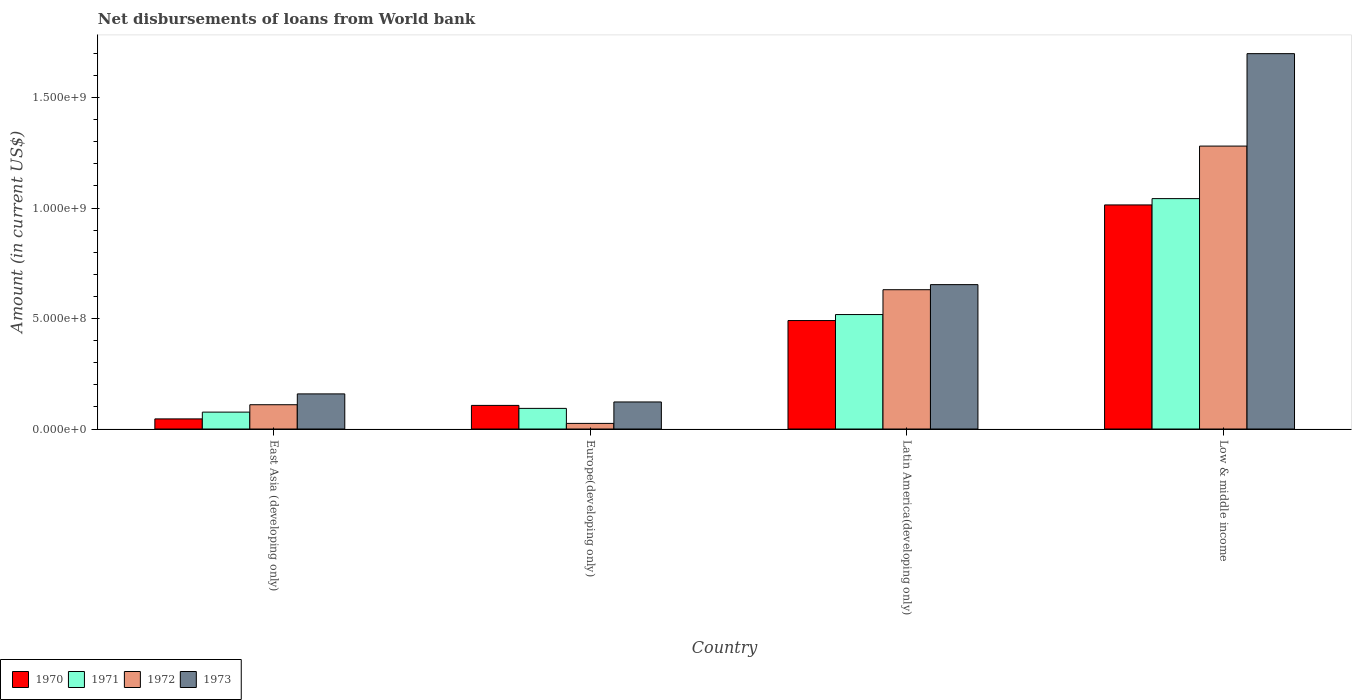How many different coloured bars are there?
Offer a terse response. 4. How many groups of bars are there?
Your answer should be very brief. 4. Are the number of bars on each tick of the X-axis equal?
Give a very brief answer. Yes. How many bars are there on the 4th tick from the right?
Provide a short and direct response. 4. What is the label of the 3rd group of bars from the left?
Your answer should be very brief. Latin America(developing only). What is the amount of loan disbursed from World Bank in 1970 in Europe(developing only)?
Ensure brevity in your answer.  1.07e+08. Across all countries, what is the maximum amount of loan disbursed from World Bank in 1970?
Ensure brevity in your answer.  1.01e+09. Across all countries, what is the minimum amount of loan disbursed from World Bank in 1971?
Ensure brevity in your answer.  7.65e+07. In which country was the amount of loan disbursed from World Bank in 1972 minimum?
Make the answer very short. Europe(developing only). What is the total amount of loan disbursed from World Bank in 1973 in the graph?
Make the answer very short. 2.63e+09. What is the difference between the amount of loan disbursed from World Bank in 1972 in East Asia (developing only) and that in Low & middle income?
Offer a terse response. -1.17e+09. What is the difference between the amount of loan disbursed from World Bank in 1972 in Europe(developing only) and the amount of loan disbursed from World Bank in 1971 in East Asia (developing only)?
Offer a terse response. -5.10e+07. What is the average amount of loan disbursed from World Bank in 1970 per country?
Provide a short and direct response. 4.14e+08. What is the difference between the amount of loan disbursed from World Bank of/in 1970 and amount of loan disbursed from World Bank of/in 1973 in Latin America(developing only)?
Offer a very short reply. -1.63e+08. In how many countries, is the amount of loan disbursed from World Bank in 1971 greater than 600000000 US$?
Provide a succinct answer. 1. What is the ratio of the amount of loan disbursed from World Bank in 1972 in Europe(developing only) to that in Latin America(developing only)?
Provide a succinct answer. 0.04. Is the amount of loan disbursed from World Bank in 1971 in Europe(developing only) less than that in Low & middle income?
Your answer should be compact. Yes. What is the difference between the highest and the second highest amount of loan disbursed from World Bank in 1972?
Make the answer very short. 6.50e+08. What is the difference between the highest and the lowest amount of loan disbursed from World Bank in 1973?
Provide a short and direct response. 1.58e+09. In how many countries, is the amount of loan disbursed from World Bank in 1970 greater than the average amount of loan disbursed from World Bank in 1970 taken over all countries?
Provide a short and direct response. 2. Is the sum of the amount of loan disbursed from World Bank in 1973 in East Asia (developing only) and Latin America(developing only) greater than the maximum amount of loan disbursed from World Bank in 1970 across all countries?
Make the answer very short. No. What does the 4th bar from the left in Low & middle income represents?
Offer a terse response. 1973. Does the graph contain grids?
Provide a short and direct response. No. Where does the legend appear in the graph?
Ensure brevity in your answer.  Bottom left. How are the legend labels stacked?
Keep it short and to the point. Horizontal. What is the title of the graph?
Your answer should be very brief. Net disbursements of loans from World bank. What is the Amount (in current US$) of 1970 in East Asia (developing only)?
Offer a terse response. 4.58e+07. What is the Amount (in current US$) in 1971 in East Asia (developing only)?
Your answer should be very brief. 7.65e+07. What is the Amount (in current US$) of 1972 in East Asia (developing only)?
Make the answer very short. 1.10e+08. What is the Amount (in current US$) in 1973 in East Asia (developing only)?
Provide a short and direct response. 1.59e+08. What is the Amount (in current US$) in 1970 in Europe(developing only)?
Offer a very short reply. 1.07e+08. What is the Amount (in current US$) of 1971 in Europe(developing only)?
Your answer should be very brief. 9.34e+07. What is the Amount (in current US$) in 1972 in Europe(developing only)?
Your answer should be very brief. 2.54e+07. What is the Amount (in current US$) of 1973 in Europe(developing only)?
Make the answer very short. 1.22e+08. What is the Amount (in current US$) of 1970 in Latin America(developing only)?
Offer a very short reply. 4.91e+08. What is the Amount (in current US$) of 1971 in Latin America(developing only)?
Make the answer very short. 5.18e+08. What is the Amount (in current US$) in 1972 in Latin America(developing only)?
Ensure brevity in your answer.  6.30e+08. What is the Amount (in current US$) in 1973 in Latin America(developing only)?
Offer a very short reply. 6.53e+08. What is the Amount (in current US$) of 1970 in Low & middle income?
Your answer should be compact. 1.01e+09. What is the Amount (in current US$) of 1971 in Low & middle income?
Make the answer very short. 1.04e+09. What is the Amount (in current US$) of 1972 in Low & middle income?
Offer a terse response. 1.28e+09. What is the Amount (in current US$) in 1973 in Low & middle income?
Provide a short and direct response. 1.70e+09. Across all countries, what is the maximum Amount (in current US$) in 1970?
Your answer should be compact. 1.01e+09. Across all countries, what is the maximum Amount (in current US$) in 1971?
Offer a terse response. 1.04e+09. Across all countries, what is the maximum Amount (in current US$) in 1972?
Ensure brevity in your answer.  1.28e+09. Across all countries, what is the maximum Amount (in current US$) in 1973?
Give a very brief answer. 1.70e+09. Across all countries, what is the minimum Amount (in current US$) of 1970?
Your answer should be compact. 4.58e+07. Across all countries, what is the minimum Amount (in current US$) of 1971?
Give a very brief answer. 7.65e+07. Across all countries, what is the minimum Amount (in current US$) in 1972?
Your answer should be very brief. 2.54e+07. Across all countries, what is the minimum Amount (in current US$) in 1973?
Provide a succinct answer. 1.22e+08. What is the total Amount (in current US$) in 1970 in the graph?
Provide a short and direct response. 1.66e+09. What is the total Amount (in current US$) of 1971 in the graph?
Provide a succinct answer. 1.73e+09. What is the total Amount (in current US$) in 1972 in the graph?
Your answer should be very brief. 2.05e+09. What is the total Amount (in current US$) in 1973 in the graph?
Your answer should be compact. 2.63e+09. What is the difference between the Amount (in current US$) of 1970 in East Asia (developing only) and that in Europe(developing only)?
Give a very brief answer. -6.11e+07. What is the difference between the Amount (in current US$) of 1971 in East Asia (developing only) and that in Europe(developing only)?
Provide a short and direct response. -1.69e+07. What is the difference between the Amount (in current US$) in 1972 in East Asia (developing only) and that in Europe(developing only)?
Ensure brevity in your answer.  8.45e+07. What is the difference between the Amount (in current US$) in 1973 in East Asia (developing only) and that in Europe(developing only)?
Provide a succinct answer. 3.64e+07. What is the difference between the Amount (in current US$) in 1970 in East Asia (developing only) and that in Latin America(developing only)?
Your response must be concise. -4.45e+08. What is the difference between the Amount (in current US$) in 1971 in East Asia (developing only) and that in Latin America(developing only)?
Provide a short and direct response. -4.42e+08. What is the difference between the Amount (in current US$) in 1972 in East Asia (developing only) and that in Latin America(developing only)?
Offer a terse response. -5.20e+08. What is the difference between the Amount (in current US$) of 1973 in East Asia (developing only) and that in Latin America(developing only)?
Ensure brevity in your answer.  -4.94e+08. What is the difference between the Amount (in current US$) of 1970 in East Asia (developing only) and that in Low & middle income?
Offer a terse response. -9.68e+08. What is the difference between the Amount (in current US$) in 1971 in East Asia (developing only) and that in Low & middle income?
Your answer should be very brief. -9.66e+08. What is the difference between the Amount (in current US$) in 1972 in East Asia (developing only) and that in Low & middle income?
Offer a terse response. -1.17e+09. What is the difference between the Amount (in current US$) of 1973 in East Asia (developing only) and that in Low & middle income?
Give a very brief answer. -1.54e+09. What is the difference between the Amount (in current US$) in 1970 in Europe(developing only) and that in Latin America(developing only)?
Offer a terse response. -3.84e+08. What is the difference between the Amount (in current US$) of 1971 in Europe(developing only) and that in Latin America(developing only)?
Provide a succinct answer. -4.25e+08. What is the difference between the Amount (in current US$) of 1972 in Europe(developing only) and that in Latin America(developing only)?
Your answer should be very brief. -6.05e+08. What is the difference between the Amount (in current US$) of 1973 in Europe(developing only) and that in Latin America(developing only)?
Offer a very short reply. -5.31e+08. What is the difference between the Amount (in current US$) in 1970 in Europe(developing only) and that in Low & middle income?
Provide a succinct answer. -9.07e+08. What is the difference between the Amount (in current US$) in 1971 in Europe(developing only) and that in Low & middle income?
Give a very brief answer. -9.49e+08. What is the difference between the Amount (in current US$) in 1972 in Europe(developing only) and that in Low & middle income?
Offer a terse response. -1.25e+09. What is the difference between the Amount (in current US$) of 1973 in Europe(developing only) and that in Low & middle income?
Give a very brief answer. -1.58e+09. What is the difference between the Amount (in current US$) of 1970 in Latin America(developing only) and that in Low & middle income?
Give a very brief answer. -5.23e+08. What is the difference between the Amount (in current US$) in 1971 in Latin America(developing only) and that in Low & middle income?
Offer a terse response. -5.25e+08. What is the difference between the Amount (in current US$) in 1972 in Latin America(developing only) and that in Low & middle income?
Keep it short and to the point. -6.50e+08. What is the difference between the Amount (in current US$) of 1973 in Latin America(developing only) and that in Low & middle income?
Provide a short and direct response. -1.05e+09. What is the difference between the Amount (in current US$) of 1970 in East Asia (developing only) and the Amount (in current US$) of 1971 in Europe(developing only)?
Provide a succinct answer. -4.76e+07. What is the difference between the Amount (in current US$) of 1970 in East Asia (developing only) and the Amount (in current US$) of 1972 in Europe(developing only)?
Provide a short and direct response. 2.03e+07. What is the difference between the Amount (in current US$) of 1970 in East Asia (developing only) and the Amount (in current US$) of 1973 in Europe(developing only)?
Give a very brief answer. -7.67e+07. What is the difference between the Amount (in current US$) of 1971 in East Asia (developing only) and the Amount (in current US$) of 1972 in Europe(developing only)?
Your answer should be very brief. 5.10e+07. What is the difference between the Amount (in current US$) in 1971 in East Asia (developing only) and the Amount (in current US$) in 1973 in Europe(developing only)?
Offer a very short reply. -4.60e+07. What is the difference between the Amount (in current US$) in 1972 in East Asia (developing only) and the Amount (in current US$) in 1973 in Europe(developing only)?
Ensure brevity in your answer.  -1.25e+07. What is the difference between the Amount (in current US$) in 1970 in East Asia (developing only) and the Amount (in current US$) in 1971 in Latin America(developing only)?
Provide a succinct answer. -4.72e+08. What is the difference between the Amount (in current US$) in 1970 in East Asia (developing only) and the Amount (in current US$) in 1972 in Latin America(developing only)?
Provide a succinct answer. -5.85e+08. What is the difference between the Amount (in current US$) in 1970 in East Asia (developing only) and the Amount (in current US$) in 1973 in Latin America(developing only)?
Make the answer very short. -6.08e+08. What is the difference between the Amount (in current US$) of 1971 in East Asia (developing only) and the Amount (in current US$) of 1972 in Latin America(developing only)?
Offer a terse response. -5.54e+08. What is the difference between the Amount (in current US$) in 1971 in East Asia (developing only) and the Amount (in current US$) in 1973 in Latin America(developing only)?
Your response must be concise. -5.77e+08. What is the difference between the Amount (in current US$) of 1972 in East Asia (developing only) and the Amount (in current US$) of 1973 in Latin America(developing only)?
Offer a very short reply. -5.43e+08. What is the difference between the Amount (in current US$) in 1970 in East Asia (developing only) and the Amount (in current US$) in 1971 in Low & middle income?
Your answer should be very brief. -9.97e+08. What is the difference between the Amount (in current US$) of 1970 in East Asia (developing only) and the Amount (in current US$) of 1972 in Low & middle income?
Your answer should be very brief. -1.23e+09. What is the difference between the Amount (in current US$) of 1970 in East Asia (developing only) and the Amount (in current US$) of 1973 in Low & middle income?
Your answer should be compact. -1.65e+09. What is the difference between the Amount (in current US$) in 1971 in East Asia (developing only) and the Amount (in current US$) in 1972 in Low & middle income?
Offer a very short reply. -1.20e+09. What is the difference between the Amount (in current US$) of 1971 in East Asia (developing only) and the Amount (in current US$) of 1973 in Low & middle income?
Ensure brevity in your answer.  -1.62e+09. What is the difference between the Amount (in current US$) in 1972 in East Asia (developing only) and the Amount (in current US$) in 1973 in Low & middle income?
Ensure brevity in your answer.  -1.59e+09. What is the difference between the Amount (in current US$) in 1970 in Europe(developing only) and the Amount (in current US$) in 1971 in Latin America(developing only)?
Make the answer very short. -4.11e+08. What is the difference between the Amount (in current US$) in 1970 in Europe(developing only) and the Amount (in current US$) in 1972 in Latin America(developing only)?
Provide a short and direct response. -5.24e+08. What is the difference between the Amount (in current US$) of 1970 in Europe(developing only) and the Amount (in current US$) of 1973 in Latin America(developing only)?
Keep it short and to the point. -5.47e+08. What is the difference between the Amount (in current US$) of 1971 in Europe(developing only) and the Amount (in current US$) of 1972 in Latin America(developing only)?
Provide a succinct answer. -5.37e+08. What is the difference between the Amount (in current US$) of 1971 in Europe(developing only) and the Amount (in current US$) of 1973 in Latin America(developing only)?
Provide a short and direct response. -5.60e+08. What is the difference between the Amount (in current US$) of 1972 in Europe(developing only) and the Amount (in current US$) of 1973 in Latin America(developing only)?
Provide a succinct answer. -6.28e+08. What is the difference between the Amount (in current US$) of 1970 in Europe(developing only) and the Amount (in current US$) of 1971 in Low & middle income?
Your answer should be very brief. -9.36e+08. What is the difference between the Amount (in current US$) in 1970 in Europe(developing only) and the Amount (in current US$) in 1972 in Low & middle income?
Keep it short and to the point. -1.17e+09. What is the difference between the Amount (in current US$) in 1970 in Europe(developing only) and the Amount (in current US$) in 1973 in Low & middle income?
Give a very brief answer. -1.59e+09. What is the difference between the Amount (in current US$) in 1971 in Europe(developing only) and the Amount (in current US$) in 1972 in Low & middle income?
Keep it short and to the point. -1.19e+09. What is the difference between the Amount (in current US$) in 1971 in Europe(developing only) and the Amount (in current US$) in 1973 in Low & middle income?
Give a very brief answer. -1.61e+09. What is the difference between the Amount (in current US$) of 1972 in Europe(developing only) and the Amount (in current US$) of 1973 in Low & middle income?
Ensure brevity in your answer.  -1.67e+09. What is the difference between the Amount (in current US$) of 1970 in Latin America(developing only) and the Amount (in current US$) of 1971 in Low & middle income?
Your answer should be very brief. -5.52e+08. What is the difference between the Amount (in current US$) of 1970 in Latin America(developing only) and the Amount (in current US$) of 1972 in Low & middle income?
Your response must be concise. -7.90e+08. What is the difference between the Amount (in current US$) of 1970 in Latin America(developing only) and the Amount (in current US$) of 1973 in Low & middle income?
Your answer should be very brief. -1.21e+09. What is the difference between the Amount (in current US$) in 1971 in Latin America(developing only) and the Amount (in current US$) in 1972 in Low & middle income?
Provide a short and direct response. -7.62e+08. What is the difference between the Amount (in current US$) of 1971 in Latin America(developing only) and the Amount (in current US$) of 1973 in Low & middle income?
Give a very brief answer. -1.18e+09. What is the difference between the Amount (in current US$) in 1972 in Latin America(developing only) and the Amount (in current US$) in 1973 in Low & middle income?
Ensure brevity in your answer.  -1.07e+09. What is the average Amount (in current US$) in 1970 per country?
Your answer should be very brief. 4.14e+08. What is the average Amount (in current US$) of 1971 per country?
Provide a short and direct response. 4.33e+08. What is the average Amount (in current US$) in 1972 per country?
Your answer should be very brief. 5.12e+08. What is the average Amount (in current US$) of 1973 per country?
Your response must be concise. 6.58e+08. What is the difference between the Amount (in current US$) in 1970 and Amount (in current US$) in 1971 in East Asia (developing only)?
Keep it short and to the point. -3.07e+07. What is the difference between the Amount (in current US$) in 1970 and Amount (in current US$) in 1972 in East Asia (developing only)?
Your response must be concise. -6.42e+07. What is the difference between the Amount (in current US$) of 1970 and Amount (in current US$) of 1973 in East Asia (developing only)?
Offer a terse response. -1.13e+08. What is the difference between the Amount (in current US$) in 1971 and Amount (in current US$) in 1972 in East Asia (developing only)?
Provide a short and direct response. -3.35e+07. What is the difference between the Amount (in current US$) of 1971 and Amount (in current US$) of 1973 in East Asia (developing only)?
Your response must be concise. -8.24e+07. What is the difference between the Amount (in current US$) of 1972 and Amount (in current US$) of 1973 in East Asia (developing only)?
Keep it short and to the point. -4.90e+07. What is the difference between the Amount (in current US$) in 1970 and Amount (in current US$) in 1971 in Europe(developing only)?
Provide a short and direct response. 1.35e+07. What is the difference between the Amount (in current US$) of 1970 and Amount (in current US$) of 1972 in Europe(developing only)?
Give a very brief answer. 8.14e+07. What is the difference between the Amount (in current US$) of 1970 and Amount (in current US$) of 1973 in Europe(developing only)?
Your answer should be very brief. -1.56e+07. What is the difference between the Amount (in current US$) of 1971 and Amount (in current US$) of 1972 in Europe(developing only)?
Offer a very short reply. 6.79e+07. What is the difference between the Amount (in current US$) of 1971 and Amount (in current US$) of 1973 in Europe(developing only)?
Give a very brief answer. -2.91e+07. What is the difference between the Amount (in current US$) in 1972 and Amount (in current US$) in 1973 in Europe(developing only)?
Provide a short and direct response. -9.70e+07. What is the difference between the Amount (in current US$) in 1970 and Amount (in current US$) in 1971 in Latin America(developing only)?
Your response must be concise. -2.71e+07. What is the difference between the Amount (in current US$) in 1970 and Amount (in current US$) in 1972 in Latin America(developing only)?
Offer a terse response. -1.40e+08. What is the difference between the Amount (in current US$) of 1970 and Amount (in current US$) of 1973 in Latin America(developing only)?
Your answer should be compact. -1.63e+08. What is the difference between the Amount (in current US$) in 1971 and Amount (in current US$) in 1972 in Latin America(developing only)?
Your answer should be compact. -1.12e+08. What is the difference between the Amount (in current US$) of 1971 and Amount (in current US$) of 1973 in Latin America(developing only)?
Offer a very short reply. -1.35e+08. What is the difference between the Amount (in current US$) in 1972 and Amount (in current US$) in 1973 in Latin America(developing only)?
Provide a short and direct response. -2.30e+07. What is the difference between the Amount (in current US$) of 1970 and Amount (in current US$) of 1971 in Low & middle income?
Provide a short and direct response. -2.86e+07. What is the difference between the Amount (in current US$) of 1970 and Amount (in current US$) of 1972 in Low & middle income?
Keep it short and to the point. -2.66e+08. What is the difference between the Amount (in current US$) of 1970 and Amount (in current US$) of 1973 in Low & middle income?
Keep it short and to the point. -6.85e+08. What is the difference between the Amount (in current US$) of 1971 and Amount (in current US$) of 1972 in Low & middle income?
Make the answer very short. -2.38e+08. What is the difference between the Amount (in current US$) in 1971 and Amount (in current US$) in 1973 in Low & middle income?
Offer a very short reply. -6.56e+08. What is the difference between the Amount (in current US$) in 1972 and Amount (in current US$) in 1973 in Low & middle income?
Ensure brevity in your answer.  -4.18e+08. What is the ratio of the Amount (in current US$) of 1970 in East Asia (developing only) to that in Europe(developing only)?
Your answer should be very brief. 0.43. What is the ratio of the Amount (in current US$) in 1971 in East Asia (developing only) to that in Europe(developing only)?
Keep it short and to the point. 0.82. What is the ratio of the Amount (in current US$) of 1972 in East Asia (developing only) to that in Europe(developing only)?
Provide a short and direct response. 4.32. What is the ratio of the Amount (in current US$) in 1973 in East Asia (developing only) to that in Europe(developing only)?
Your response must be concise. 1.3. What is the ratio of the Amount (in current US$) in 1970 in East Asia (developing only) to that in Latin America(developing only)?
Keep it short and to the point. 0.09. What is the ratio of the Amount (in current US$) of 1971 in East Asia (developing only) to that in Latin America(developing only)?
Provide a succinct answer. 0.15. What is the ratio of the Amount (in current US$) of 1972 in East Asia (developing only) to that in Latin America(developing only)?
Ensure brevity in your answer.  0.17. What is the ratio of the Amount (in current US$) of 1973 in East Asia (developing only) to that in Latin America(developing only)?
Ensure brevity in your answer.  0.24. What is the ratio of the Amount (in current US$) in 1970 in East Asia (developing only) to that in Low & middle income?
Make the answer very short. 0.05. What is the ratio of the Amount (in current US$) in 1971 in East Asia (developing only) to that in Low & middle income?
Your answer should be compact. 0.07. What is the ratio of the Amount (in current US$) in 1972 in East Asia (developing only) to that in Low & middle income?
Give a very brief answer. 0.09. What is the ratio of the Amount (in current US$) of 1973 in East Asia (developing only) to that in Low & middle income?
Provide a succinct answer. 0.09. What is the ratio of the Amount (in current US$) of 1970 in Europe(developing only) to that in Latin America(developing only)?
Your answer should be compact. 0.22. What is the ratio of the Amount (in current US$) of 1971 in Europe(developing only) to that in Latin America(developing only)?
Keep it short and to the point. 0.18. What is the ratio of the Amount (in current US$) in 1972 in Europe(developing only) to that in Latin America(developing only)?
Keep it short and to the point. 0.04. What is the ratio of the Amount (in current US$) of 1973 in Europe(developing only) to that in Latin America(developing only)?
Your response must be concise. 0.19. What is the ratio of the Amount (in current US$) in 1970 in Europe(developing only) to that in Low & middle income?
Your answer should be very brief. 0.11. What is the ratio of the Amount (in current US$) of 1971 in Europe(developing only) to that in Low & middle income?
Your answer should be compact. 0.09. What is the ratio of the Amount (in current US$) in 1972 in Europe(developing only) to that in Low & middle income?
Provide a short and direct response. 0.02. What is the ratio of the Amount (in current US$) in 1973 in Europe(developing only) to that in Low & middle income?
Keep it short and to the point. 0.07. What is the ratio of the Amount (in current US$) of 1970 in Latin America(developing only) to that in Low & middle income?
Your response must be concise. 0.48. What is the ratio of the Amount (in current US$) in 1971 in Latin America(developing only) to that in Low & middle income?
Provide a short and direct response. 0.5. What is the ratio of the Amount (in current US$) of 1972 in Latin America(developing only) to that in Low & middle income?
Keep it short and to the point. 0.49. What is the ratio of the Amount (in current US$) of 1973 in Latin America(developing only) to that in Low & middle income?
Make the answer very short. 0.38. What is the difference between the highest and the second highest Amount (in current US$) of 1970?
Offer a terse response. 5.23e+08. What is the difference between the highest and the second highest Amount (in current US$) of 1971?
Keep it short and to the point. 5.25e+08. What is the difference between the highest and the second highest Amount (in current US$) in 1972?
Provide a succinct answer. 6.50e+08. What is the difference between the highest and the second highest Amount (in current US$) in 1973?
Ensure brevity in your answer.  1.05e+09. What is the difference between the highest and the lowest Amount (in current US$) of 1970?
Give a very brief answer. 9.68e+08. What is the difference between the highest and the lowest Amount (in current US$) in 1971?
Make the answer very short. 9.66e+08. What is the difference between the highest and the lowest Amount (in current US$) in 1972?
Keep it short and to the point. 1.25e+09. What is the difference between the highest and the lowest Amount (in current US$) of 1973?
Your answer should be very brief. 1.58e+09. 